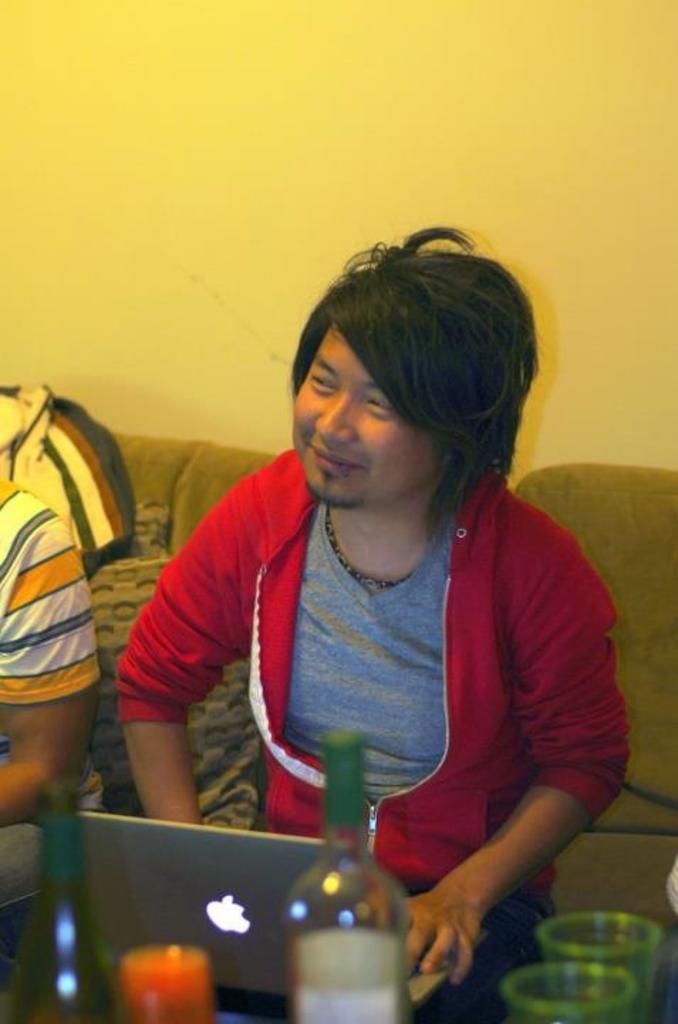How many people are in the image? There are two people in the image. What are the people doing in the image? The people are sitting on a couch. What objects are in front of the people? There is a laptop, bottles, and glasses in front of the people. What can be seen behind the people? There is a wall behind the people. What type of twig is being used as a prop in the image? There is no twig present in the image. What month is it in the image? The image does not provide any information about the month or time of year. 